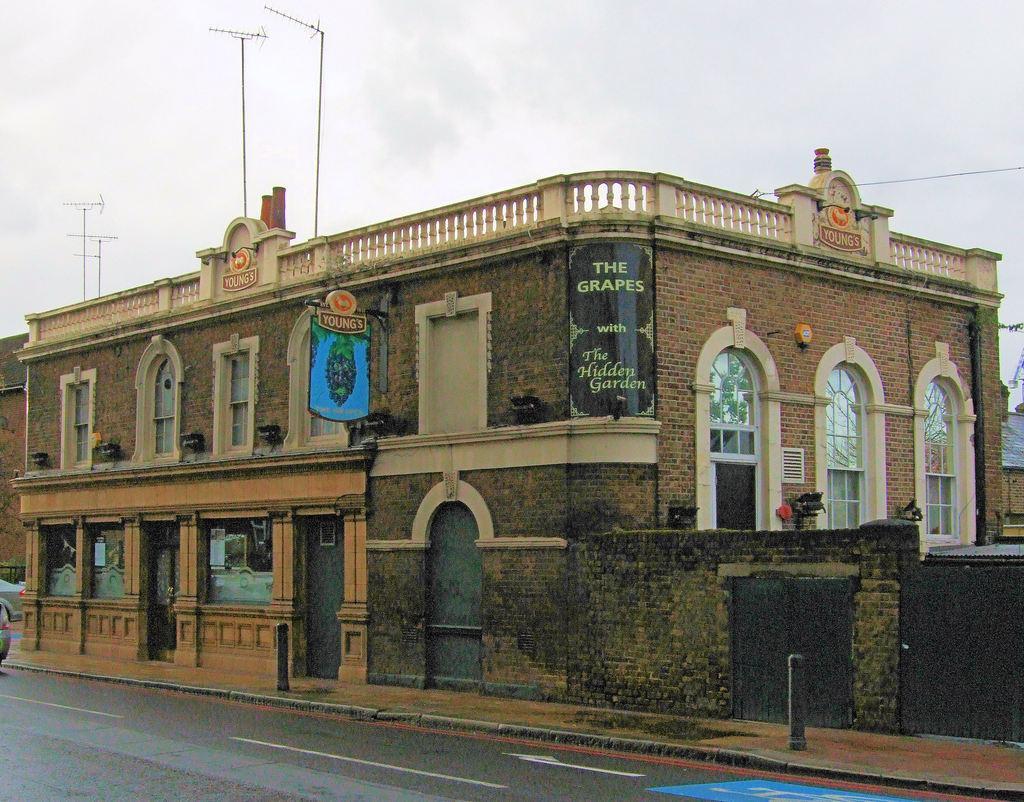Could you give a brief overview of what you see in this image? In this image I can see a building which is brown and cream in color and a board which is blue in color attached to it. I can see the road and few vehicles on the road and I can see the sidewalk and few poles on the sidewalk. In the background I can see few antennas and the sky. 